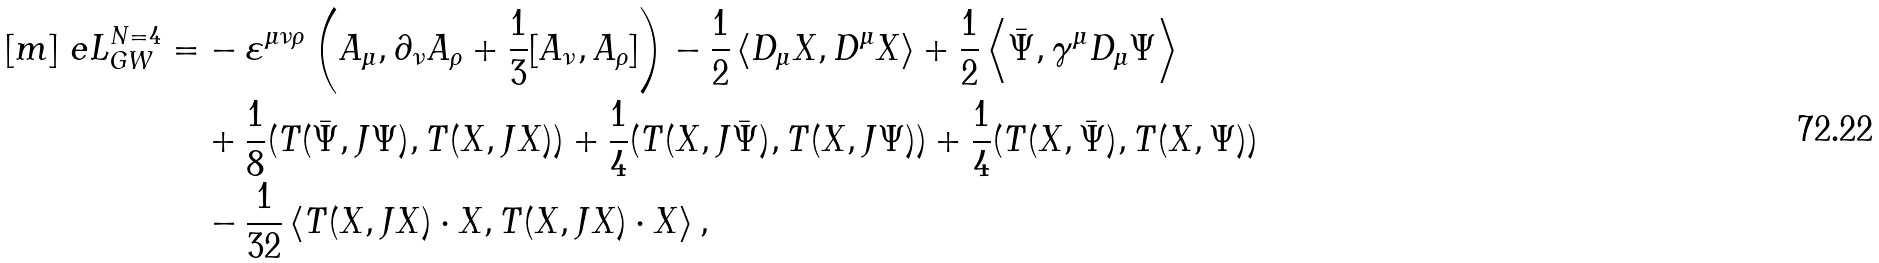Convert formula to latex. <formula><loc_0><loc_0><loc_500><loc_500>[ m ] \ e L _ { G W } ^ { N = 4 } = & - \varepsilon ^ { \mu \nu \rho } \left ( A _ { \mu } , \partial _ { \nu } A _ { \rho } + \frac { 1 } { 3 } [ A _ { \nu } , A _ { \rho } ] \right ) - \frac { 1 } { 2 } \left < D _ { \mu } X , D ^ { \mu } X \right > + \frac { 1 } { 2 } \left < { \bar { \Psi } } , \gamma ^ { \mu } D _ { \mu } \Psi \right > \\ & + \frac { 1 } { 8 } ( T ( { \bar { \Psi } } , J \Psi ) , T ( X , J X ) ) + \frac { 1 } { 4 } ( T ( X , J { \bar { \Psi } } ) , T ( X , J \Psi ) ) + \frac { 1 } { 4 } ( T ( X , { \bar { \Psi } } ) , T ( X , \Psi ) ) \\ & - \frac { 1 } { 3 2 } \left < T ( X , J X ) \cdot X , T ( X , J X ) \cdot X \right > ,</formula> 